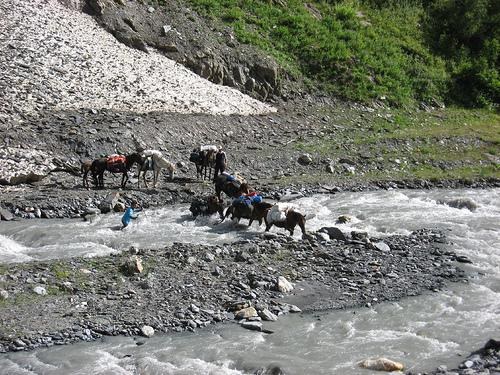Where are these animals located? Please explain your reasoning. mountains. The animals are in the mountains. 